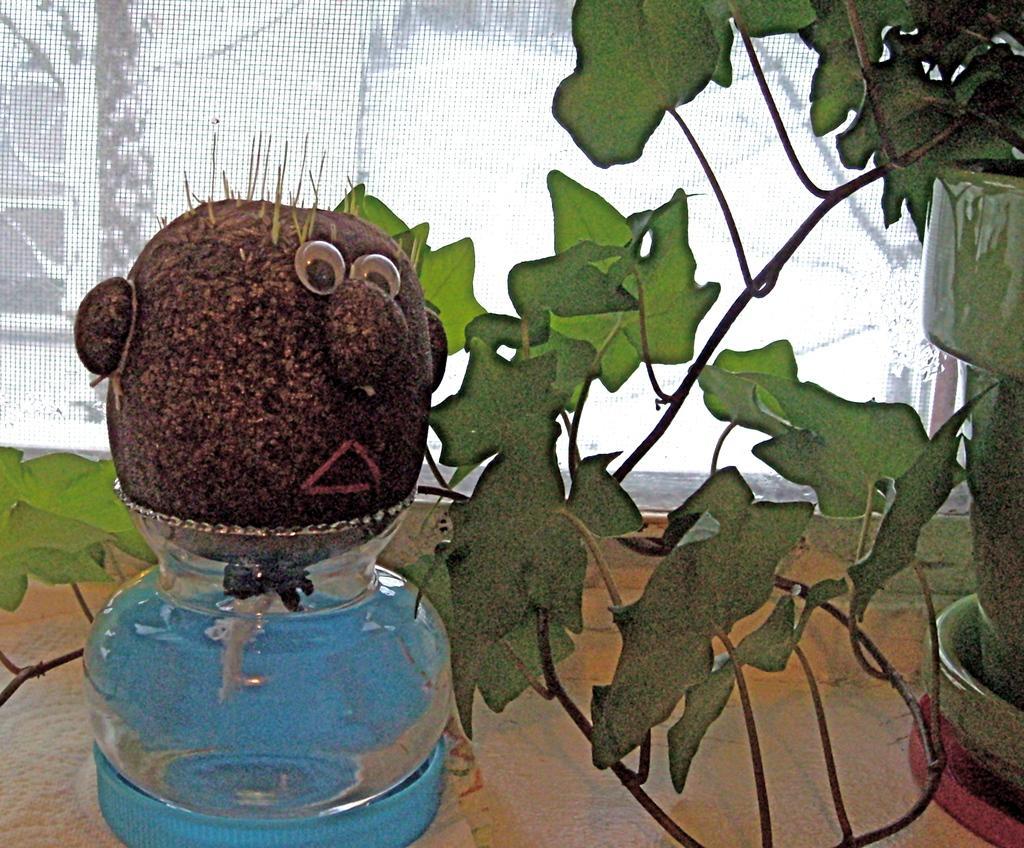In one or two sentences, can you explain what this image depicts? It is an editing picture. On the right side of the image we can see one plant pot, which is in green color and we can see one plant. On the left side of the image we can one glass pot in the blue bowl. On the glass pot, we can see one object, which is in brown color and we can see some human face feature on it. In the background there is a banner and a few other objects. 